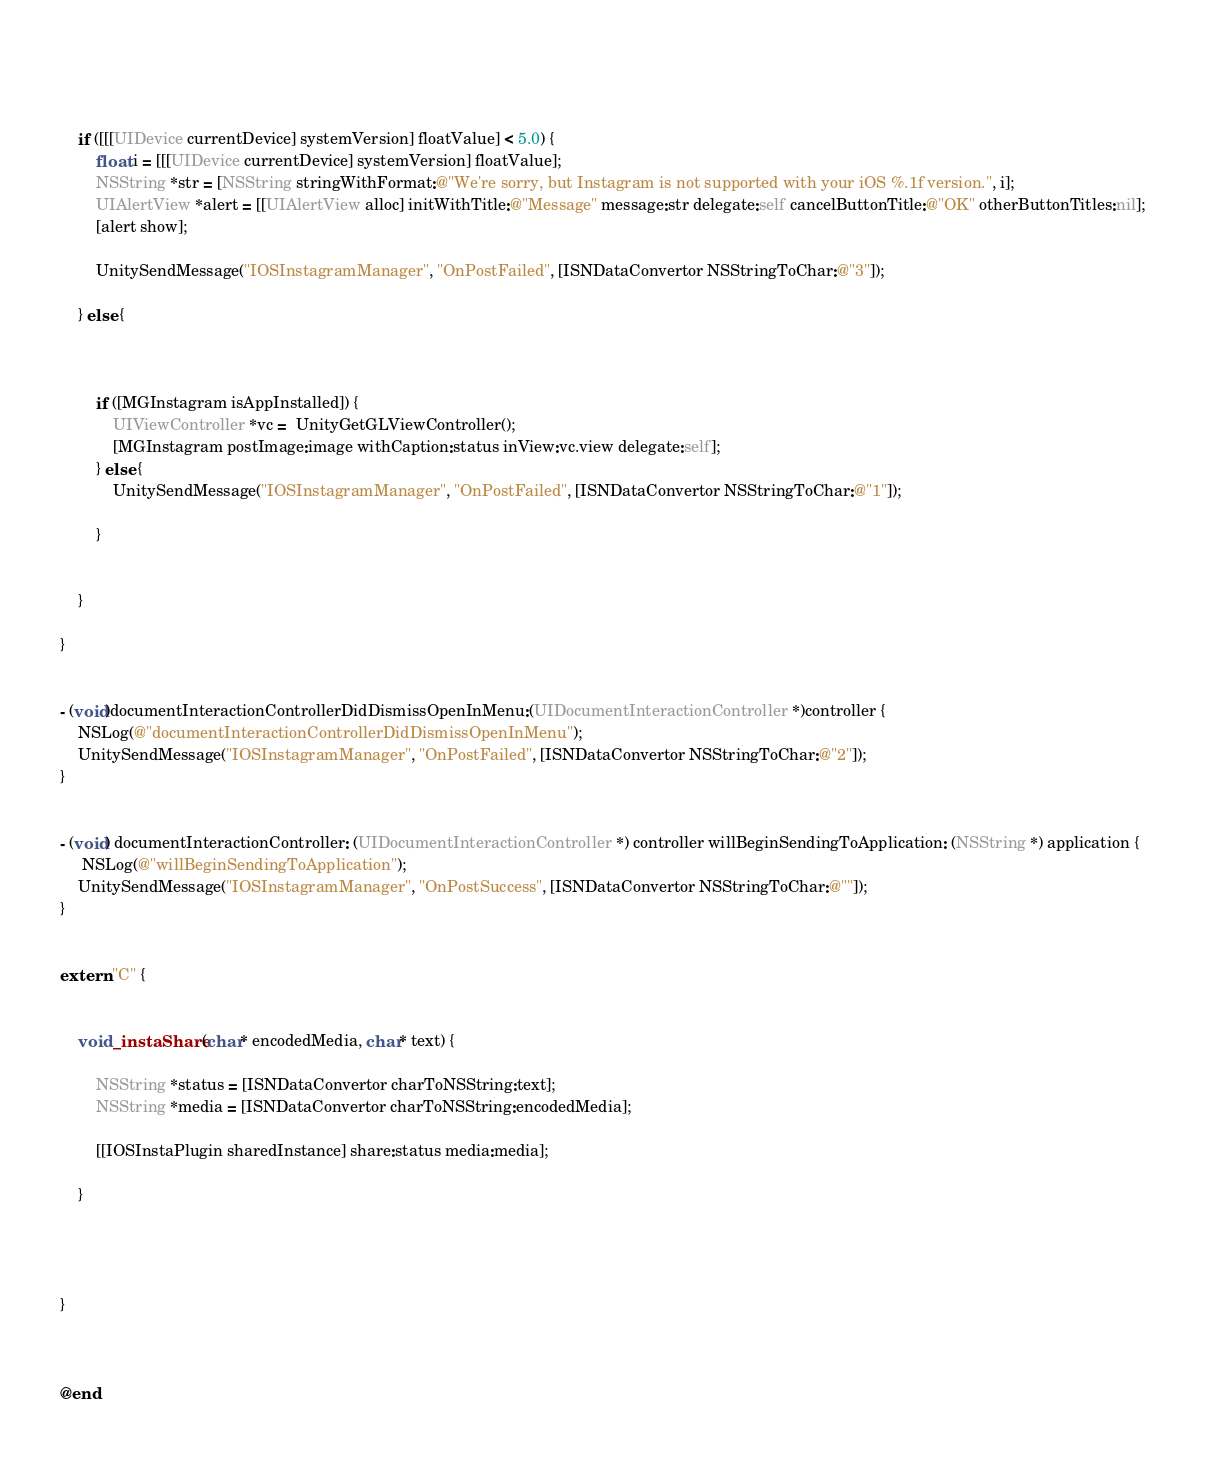Convert code to text. <code><loc_0><loc_0><loc_500><loc_500><_ObjectiveC_>    
    
    
    if ([[[UIDevice currentDevice] systemVersion] floatValue] < 5.0) {
        float i = [[[UIDevice currentDevice] systemVersion] floatValue];
        NSString *str = [NSString stringWithFormat:@"We're sorry, but Instagram is not supported with your iOS %.1f version.", i];
        UIAlertView *alert = [[UIAlertView alloc] initWithTitle:@"Message" message:str delegate:self cancelButtonTitle:@"OK" otherButtonTitles:nil];
        [alert show];
        
        UnitySendMessage("IOSInstagramManager", "OnPostFailed", [ISNDataConvertor NSStringToChar:@"3"]);

    } else {
        
        
        
        if ([MGInstagram isAppInstalled]) {
            UIViewController *vc =  UnityGetGLViewController();
            [MGInstagram postImage:image withCaption:status inView:vc.view delegate:self];
        } else {
            UnitySendMessage("IOSInstagramManager", "OnPostFailed", [ISNDataConvertor NSStringToChar:@"1"]);

        }
        
        
    }
    
}


- (void)documentInteractionControllerDidDismissOpenInMenu:(UIDocumentInteractionController *)controller {
    NSLog(@"documentInteractionControllerDidDismissOpenInMenu");
    UnitySendMessage("IOSInstagramManager", "OnPostFailed", [ISNDataConvertor NSStringToChar:@"2"]);
}


- (void) documentInteractionController: (UIDocumentInteractionController *) controller willBeginSendingToApplication: (NSString *) application {
     NSLog(@"willBeginSendingToApplication");
    UnitySendMessage("IOSInstagramManager", "OnPostSuccess", [ISNDataConvertor NSStringToChar:@""]);
}


extern "C" {
    
    
    void _instaShare(char* encodedMedia, char* text) {
        
        NSString *status = [ISNDataConvertor charToNSString:text];
        NSString *media = [ISNDataConvertor charToNSString:encodedMedia];
        
        [[IOSInstaPlugin sharedInstance] share:status media:media];
        
    }
    
    
    
    
}



@end

</code> 